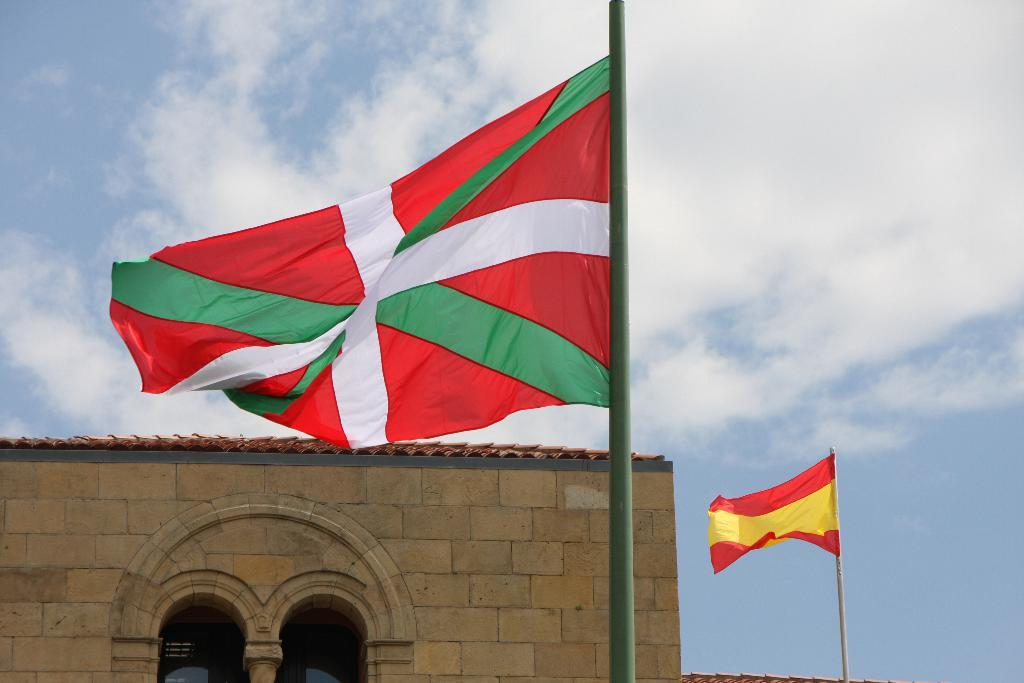What type of structure is present in the image? There is a building in the image. What objects are present near the building? There are two poles and two flags in the image. What can be seen in the background of the image? There are clouds and the sky visible in the background of the image. What type of riddle can be solved by looking at the flags in the image? There is no riddle associated with the flags in the image. What type of apparatus is used to explore space in the image? There is no apparatus for exploring space present in the image. 